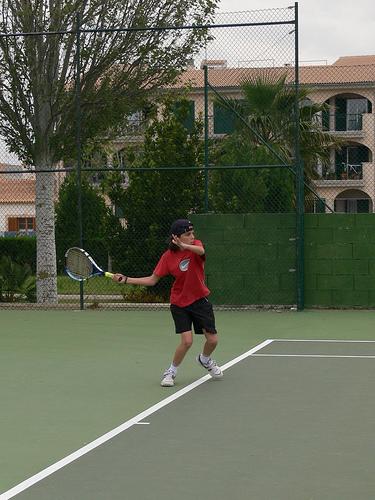What game is he playing?
Write a very short answer. Tennis. How tall is the fence?
Keep it brief. 20 feet. Did he step over the boundary line?
Keep it brief. Yes. What color is the man's t-shirt?
Short answer required. Red. What color is the man's shirt?
Short answer required. Red. What sport is this?
Answer briefly. Tennis. 